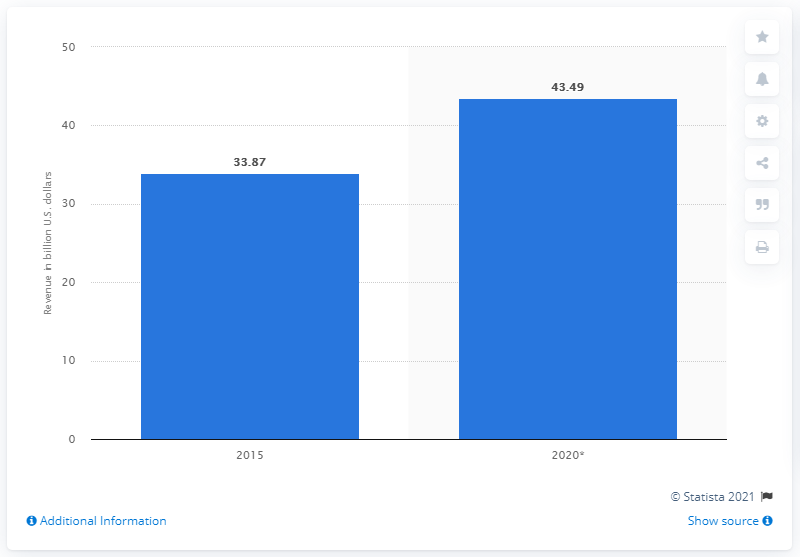Point out several critical features in this image. In 2015, the music market was estimated to be worth the most. 